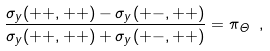<formula> <loc_0><loc_0><loc_500><loc_500>\frac { \sigma _ { y } ( + + , + + ) - \sigma _ { y } ( + - , + + ) } { \sigma _ { y } ( + + , + + ) + \sigma _ { y } ( + - , + + ) } = \pi _ { \Theta } \ ,</formula> 